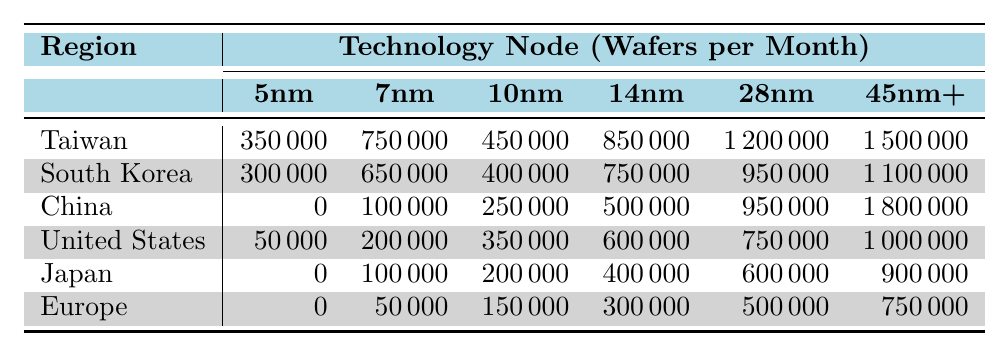What is the manufacturing capacity for 5nm technology in Taiwan? The table shows a specific column for 5nm technology under the region of Taiwan, which indicates a manufacturing capacity of 350,000 wafers per month.
Answer: 350,000 Which region has the highest capacity for 7nm technology? By comparing all values under the 7nm column, Taiwan has the highest capacity at 750,000 wafers per month.
Answer: Taiwan Is there any region with a capacity of zero for 5nm technology? Looking at the 5nm column, both China and Europe have a manufacturing capacity of zero.
Answer: Yes What is the total manufacturing capacity for 28nm technology across all regions? Summing the capacities for 28nm technology from all regions: 1,200,000 (Taiwan) + 950,000 (South Korea) + 950,000 (China) + 750,000 (United States) + 600,000 (Japan) + 500,000 (Europe) equals 4,000,000 wafers per month.
Answer: 4,000,000 Which region manufactures the least number of wafers for 10nm technology? In the 10nm column, identifying the smallest value shows that Europe has the lowest capacity at 150,000 wafers per month.
Answer: Europe What is the difference in manufacturing capacity for 14nm technology between Taiwan and the United States? The capacity for 14nm technology in Taiwan is 850,000, while in the United States, it is 600,000. The difference is 850,000 - 600,000 = 250,000 wafers per month.
Answer: 250,000 Which region has the highest overall capacity for all technology nodes combined? To determine the highest total capacity, we sum the capacities for all technology nodes by region: Taiwan = 3,500,000; South Korea = 2,650,000; China = 2,850,000; United States = 2,000,000; Japan = 1,300,000; Europe = 1,000,000. Taiwan has the highest total.
Answer: Taiwan How many regions have a manufacturing capacity between 500,000 and 1,000,000 for 28nm technology? In the 28nm column, only Taiwan, South Korea, and China have capacities of 1,200,000, 950,000, and 950,000 respectively; only South Korea and China fit the criteria of being under 1,000,000 but above 500,000. So, there are 2 regions.
Answer: 2 Is the capacity for 45nm and above technology higher in China than in Japan? Looking at the 45nm and above column, China has a capacity of 1,800,000, while Japan has 900,000. China’s capacity is indeed higher than Japan’s.
Answer: Yes What is the average capacity for 7nm technology across all regions? Summing the capacities for 7nm technology: 750,000 (Taiwan) + 650,000 (South Korea) + 100,000 (China) + 200,000 (United States) + 100,000 (Japan) + 50,000 (Europe) = 1,850,000. Dividing by the number of regions (6) gives an average of 308,333.33.
Answer: 308,333.33 